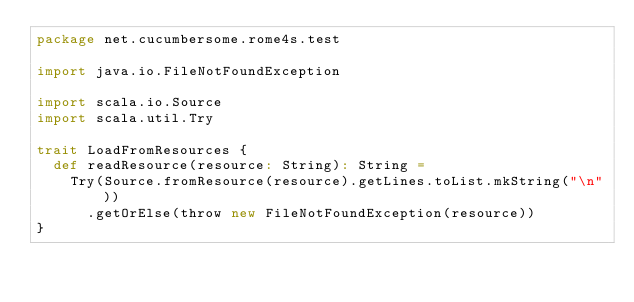<code> <loc_0><loc_0><loc_500><loc_500><_Scala_>package net.cucumbersome.rome4s.test

import java.io.FileNotFoundException

import scala.io.Source
import scala.util.Try

trait LoadFromResources {
  def readResource(resource: String): String =
    Try(Source.fromResource(resource).getLines.toList.mkString("\n"))
      .getOrElse(throw new FileNotFoundException(resource))
}
</code> 